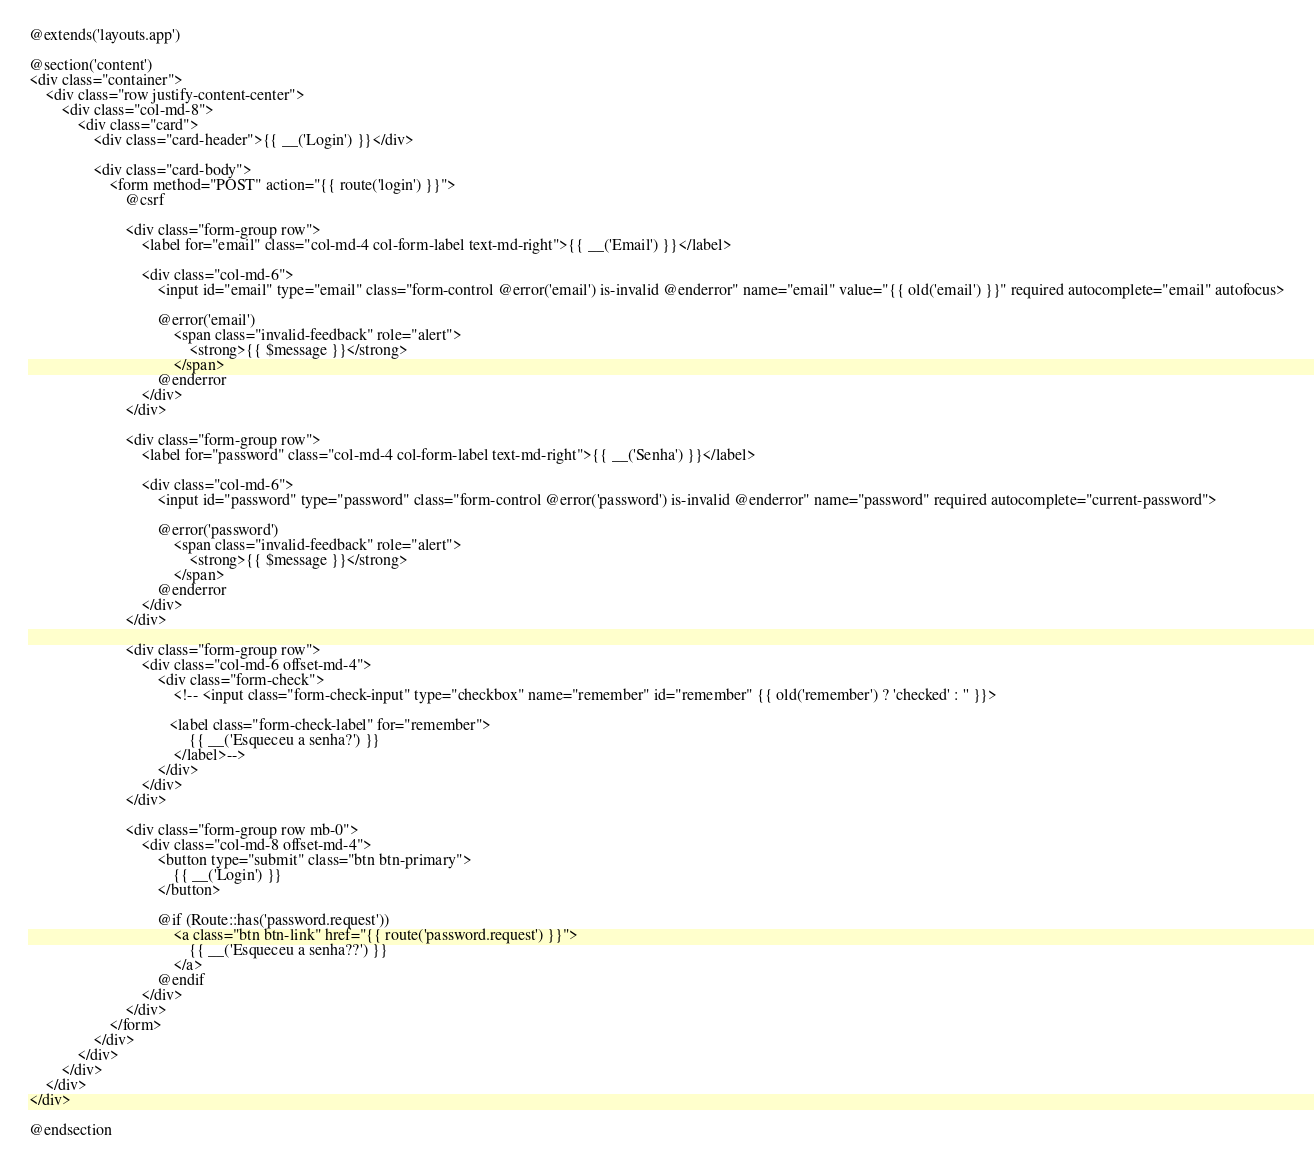Convert code to text. <code><loc_0><loc_0><loc_500><loc_500><_PHP_>@extends('layouts.app')

@section('content')
<div class="container">
    <div class="row justify-content-center">
        <div class="col-md-8">
            <div class="card">
                <div class="card-header">{{ __('Login') }}</div>

                <div class="card-body">
                    <form method="POST" action="{{ route('login') }}">
                        @csrf

                        <div class="form-group row">
                            <label for="email" class="col-md-4 col-form-label text-md-right">{{ __('Email') }}</label>

                            <div class="col-md-6">
                                <input id="email" type="email" class="form-control @error('email') is-invalid @enderror" name="email" value="{{ old('email') }}" required autocomplete="email" autofocus>

                                @error('email')
                                    <span class="invalid-feedback" role="alert">
                                        <strong>{{ $message }}</strong>
                                    </span>
                                @enderror
                            </div>
                        </div>

                        <div class="form-group row">
                            <label for="password" class="col-md-4 col-form-label text-md-right">{{ __('Senha') }}</label>

                            <div class="col-md-6">
                                <input id="password" type="password" class="form-control @error('password') is-invalid @enderror" name="password" required autocomplete="current-password">

                                @error('password')
                                    <span class="invalid-feedback" role="alert">
                                        <strong>{{ $message }}</strong>
                                    </span>
                                @enderror
                            </div>
                        </div>

                        <div class="form-group row">
                            <div class="col-md-6 offset-md-4">
                                <div class="form-check">
                                    <!-- <input class="form-check-input" type="checkbox" name="remember" id="remember" {{ old('remember') ? 'checked' : '' }}>

                                   <label class="form-check-label" for="remember">
                                        {{ __('Esqueceu a senha?') }}
                                    </label>-->
                                </div>
                            </div>
                        </div>

                        <div class="form-group row mb-0">
                            <div class="col-md-8 offset-md-4">
                                <button type="submit" class="btn btn-primary">
                                    {{ __('Login') }}
                                </button>

                                @if (Route::has('password.request'))
                                    <a class="btn btn-link" href="{{ route('password.request') }}">
                                        {{ __('Esqueceu a senha??') }}
                                    </a>
                                @endif
                            </div>
                        </div>
                    </form>
                </div>
            </div>
        </div>
    </div>
</div>

@endsection
</code> 